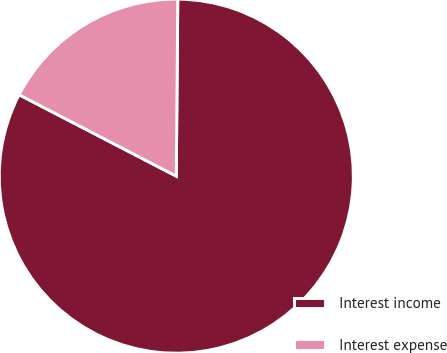Convert chart to OTSL. <chart><loc_0><loc_0><loc_500><loc_500><pie_chart><fcel>Interest income<fcel>Interest expense<nl><fcel>82.47%<fcel>17.53%<nl></chart> 